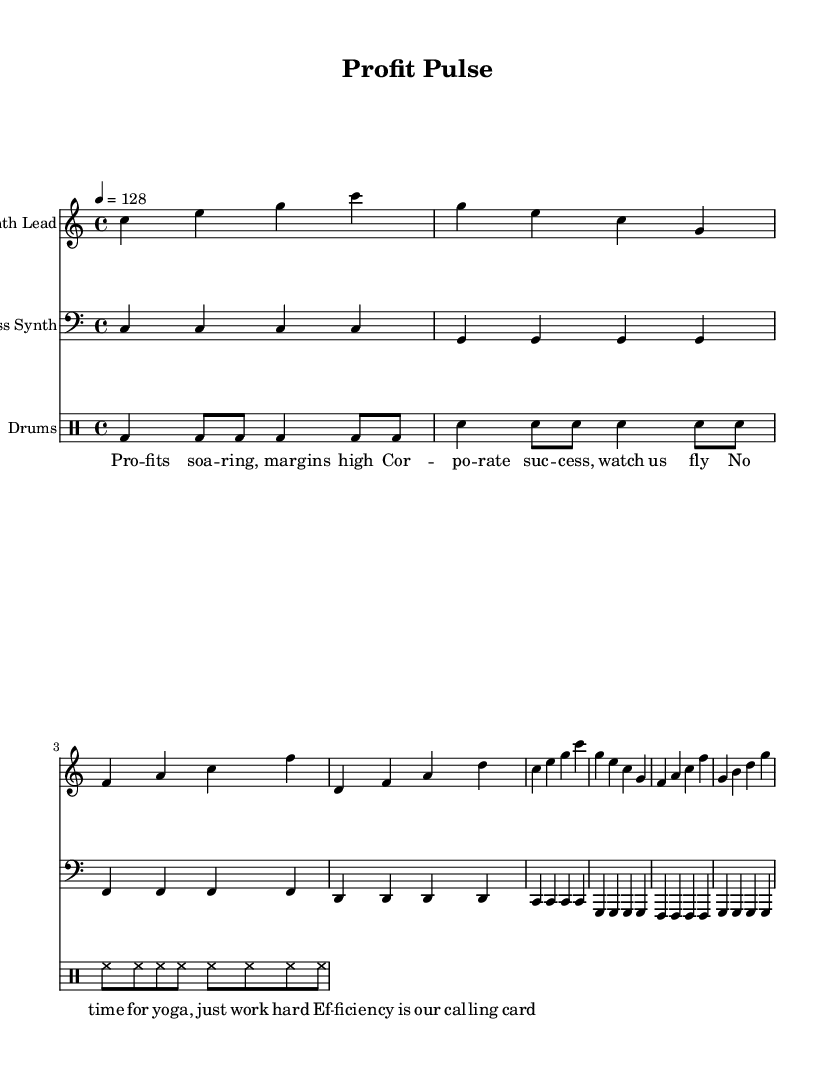What is the key signature of this music? The key signature is indicated at the beginning of the score, showing no sharps or flats, which corresponds to C major.
Answer: C major What is the time signature of this music? The time signature appears prominently at the start of the score, and it shows a 4/4 time signature, which means there are four beats in each measure.
Answer: 4/4 What is the tempo marking for this piece? The tempo marking, indicated at the beginning with "4 = 128," shows that there are 128 beats per minute, which translates to a fast-paced tempo.
Answer: 128 How many measures are there in the Synth Lead section? By counting the measures in the Synth Lead staff, there are 8 distinct measures, confirming its structure.
Answer: 8 What text appears in the lyrics section? The lyrics are laid out beneath the staff and can be read straightforwardly, expressing sentiments about corporate success and efficiency.
Answer: Profits soaring, margins high What type of synthesizer is featured as the lead instrument? The instrument specified for the Synth Lead is a synth, noted in the staff headers and indicates an electronic characteristic fitting for dance music.
Answer: Synth Lead What rhythmic elements are used in the drum machine section? The drum machine section distinctly shows a pattern of bass drum, snare, and hi-hat hits, which are standard in dance music rhythms.
Answer: Bass drum, snare, hi-hat 